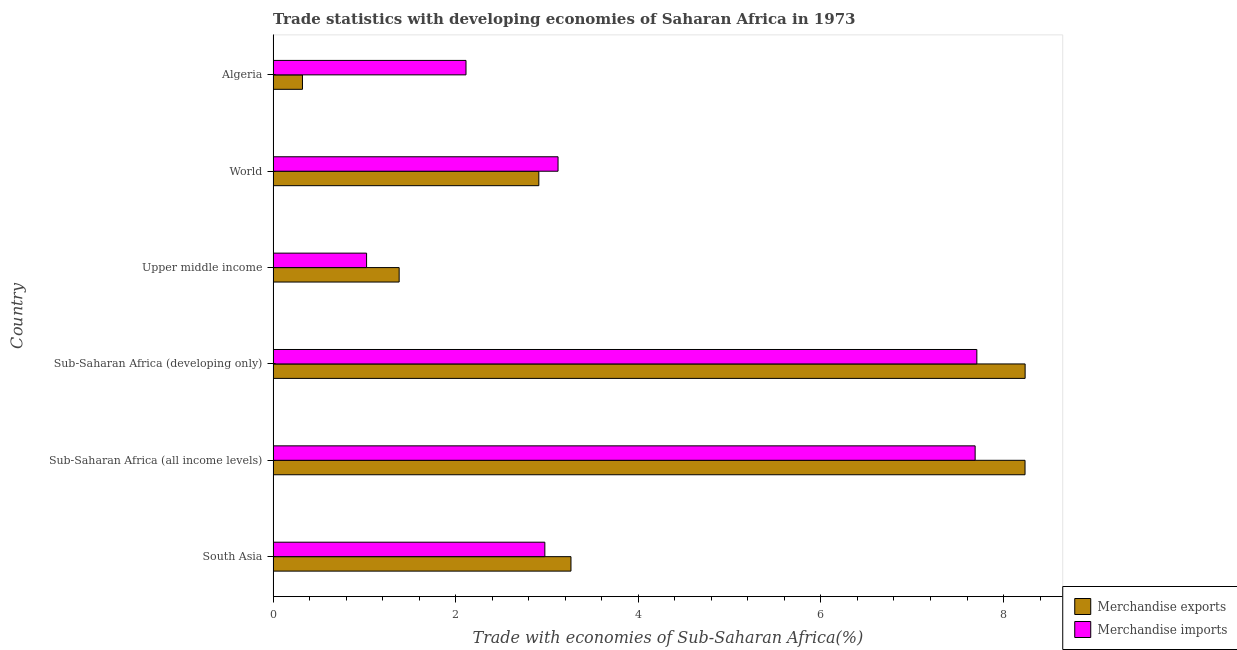How many different coloured bars are there?
Provide a succinct answer. 2. How many groups of bars are there?
Offer a very short reply. 6. Are the number of bars on each tick of the Y-axis equal?
Ensure brevity in your answer.  Yes. How many bars are there on the 6th tick from the bottom?
Your response must be concise. 2. What is the label of the 6th group of bars from the top?
Your response must be concise. South Asia. In how many cases, is the number of bars for a given country not equal to the number of legend labels?
Give a very brief answer. 0. What is the merchandise imports in South Asia?
Keep it short and to the point. 2.98. Across all countries, what is the maximum merchandise imports?
Provide a short and direct response. 7.71. Across all countries, what is the minimum merchandise exports?
Offer a very short reply. 0.32. In which country was the merchandise imports maximum?
Your response must be concise. Sub-Saharan Africa (developing only). In which country was the merchandise imports minimum?
Keep it short and to the point. Upper middle income. What is the total merchandise imports in the graph?
Make the answer very short. 24.63. What is the difference between the merchandise imports in Upper middle income and that in World?
Your answer should be compact. -2.1. What is the difference between the merchandise imports in World and the merchandise exports in Sub-Saharan Africa (developing only)?
Make the answer very short. -5.12. What is the average merchandise imports per country?
Provide a short and direct response. 4.11. What is the difference between the merchandise exports and merchandise imports in World?
Your answer should be compact. -0.21. What is the ratio of the merchandise imports in Algeria to that in South Asia?
Make the answer very short. 0.71. Is the difference between the merchandise imports in Sub-Saharan Africa (developing only) and Upper middle income greater than the difference between the merchandise exports in Sub-Saharan Africa (developing only) and Upper middle income?
Your response must be concise. No. What is the difference between the highest and the lowest merchandise exports?
Ensure brevity in your answer.  7.92. In how many countries, is the merchandise imports greater than the average merchandise imports taken over all countries?
Provide a short and direct response. 2. What does the 1st bar from the top in Upper middle income represents?
Provide a short and direct response. Merchandise imports. What is the difference between two consecutive major ticks on the X-axis?
Give a very brief answer. 2. Where does the legend appear in the graph?
Give a very brief answer. Bottom right. How are the legend labels stacked?
Your response must be concise. Vertical. What is the title of the graph?
Offer a very short reply. Trade statistics with developing economies of Saharan Africa in 1973. What is the label or title of the X-axis?
Offer a terse response. Trade with economies of Sub-Saharan Africa(%). What is the label or title of the Y-axis?
Your answer should be very brief. Country. What is the Trade with economies of Sub-Saharan Africa(%) in Merchandise exports in South Asia?
Give a very brief answer. 3.26. What is the Trade with economies of Sub-Saharan Africa(%) of Merchandise imports in South Asia?
Make the answer very short. 2.98. What is the Trade with economies of Sub-Saharan Africa(%) of Merchandise exports in Sub-Saharan Africa (all income levels)?
Provide a short and direct response. 8.24. What is the Trade with economies of Sub-Saharan Africa(%) of Merchandise imports in Sub-Saharan Africa (all income levels)?
Give a very brief answer. 7.69. What is the Trade with economies of Sub-Saharan Africa(%) in Merchandise exports in Sub-Saharan Africa (developing only)?
Provide a succinct answer. 8.24. What is the Trade with economies of Sub-Saharan Africa(%) of Merchandise imports in Sub-Saharan Africa (developing only)?
Keep it short and to the point. 7.71. What is the Trade with economies of Sub-Saharan Africa(%) of Merchandise exports in Upper middle income?
Your answer should be very brief. 1.38. What is the Trade with economies of Sub-Saharan Africa(%) of Merchandise imports in Upper middle income?
Your answer should be very brief. 1.02. What is the Trade with economies of Sub-Saharan Africa(%) in Merchandise exports in World?
Keep it short and to the point. 2.91. What is the Trade with economies of Sub-Saharan Africa(%) of Merchandise imports in World?
Give a very brief answer. 3.12. What is the Trade with economies of Sub-Saharan Africa(%) in Merchandise exports in Algeria?
Ensure brevity in your answer.  0.32. What is the Trade with economies of Sub-Saharan Africa(%) of Merchandise imports in Algeria?
Offer a very short reply. 2.11. Across all countries, what is the maximum Trade with economies of Sub-Saharan Africa(%) in Merchandise exports?
Provide a succinct answer. 8.24. Across all countries, what is the maximum Trade with economies of Sub-Saharan Africa(%) in Merchandise imports?
Make the answer very short. 7.71. Across all countries, what is the minimum Trade with economies of Sub-Saharan Africa(%) in Merchandise exports?
Ensure brevity in your answer.  0.32. Across all countries, what is the minimum Trade with economies of Sub-Saharan Africa(%) of Merchandise imports?
Offer a very short reply. 1.02. What is the total Trade with economies of Sub-Saharan Africa(%) of Merchandise exports in the graph?
Your answer should be very brief. 24.35. What is the total Trade with economies of Sub-Saharan Africa(%) of Merchandise imports in the graph?
Make the answer very short. 24.63. What is the difference between the Trade with economies of Sub-Saharan Africa(%) in Merchandise exports in South Asia and that in Sub-Saharan Africa (all income levels)?
Provide a short and direct response. -4.97. What is the difference between the Trade with economies of Sub-Saharan Africa(%) of Merchandise imports in South Asia and that in Sub-Saharan Africa (all income levels)?
Your response must be concise. -4.71. What is the difference between the Trade with economies of Sub-Saharan Africa(%) of Merchandise exports in South Asia and that in Sub-Saharan Africa (developing only)?
Your response must be concise. -4.97. What is the difference between the Trade with economies of Sub-Saharan Africa(%) in Merchandise imports in South Asia and that in Sub-Saharan Africa (developing only)?
Give a very brief answer. -4.73. What is the difference between the Trade with economies of Sub-Saharan Africa(%) of Merchandise exports in South Asia and that in Upper middle income?
Your response must be concise. 1.88. What is the difference between the Trade with economies of Sub-Saharan Africa(%) in Merchandise imports in South Asia and that in Upper middle income?
Your answer should be compact. 1.95. What is the difference between the Trade with economies of Sub-Saharan Africa(%) of Merchandise exports in South Asia and that in World?
Offer a very short reply. 0.35. What is the difference between the Trade with economies of Sub-Saharan Africa(%) in Merchandise imports in South Asia and that in World?
Your response must be concise. -0.14. What is the difference between the Trade with economies of Sub-Saharan Africa(%) of Merchandise exports in South Asia and that in Algeria?
Offer a terse response. 2.94. What is the difference between the Trade with economies of Sub-Saharan Africa(%) of Merchandise imports in South Asia and that in Algeria?
Keep it short and to the point. 0.86. What is the difference between the Trade with economies of Sub-Saharan Africa(%) in Merchandise exports in Sub-Saharan Africa (all income levels) and that in Sub-Saharan Africa (developing only)?
Offer a terse response. -0. What is the difference between the Trade with economies of Sub-Saharan Africa(%) in Merchandise imports in Sub-Saharan Africa (all income levels) and that in Sub-Saharan Africa (developing only)?
Your answer should be compact. -0.02. What is the difference between the Trade with economies of Sub-Saharan Africa(%) of Merchandise exports in Sub-Saharan Africa (all income levels) and that in Upper middle income?
Your answer should be compact. 6.86. What is the difference between the Trade with economies of Sub-Saharan Africa(%) of Merchandise imports in Sub-Saharan Africa (all income levels) and that in Upper middle income?
Your response must be concise. 6.67. What is the difference between the Trade with economies of Sub-Saharan Africa(%) in Merchandise exports in Sub-Saharan Africa (all income levels) and that in World?
Your response must be concise. 5.33. What is the difference between the Trade with economies of Sub-Saharan Africa(%) in Merchandise imports in Sub-Saharan Africa (all income levels) and that in World?
Your answer should be compact. 4.57. What is the difference between the Trade with economies of Sub-Saharan Africa(%) of Merchandise exports in Sub-Saharan Africa (all income levels) and that in Algeria?
Give a very brief answer. 7.91. What is the difference between the Trade with economies of Sub-Saharan Africa(%) in Merchandise imports in Sub-Saharan Africa (all income levels) and that in Algeria?
Offer a terse response. 5.58. What is the difference between the Trade with economies of Sub-Saharan Africa(%) of Merchandise exports in Sub-Saharan Africa (developing only) and that in Upper middle income?
Keep it short and to the point. 6.86. What is the difference between the Trade with economies of Sub-Saharan Africa(%) of Merchandise imports in Sub-Saharan Africa (developing only) and that in Upper middle income?
Your answer should be compact. 6.68. What is the difference between the Trade with economies of Sub-Saharan Africa(%) in Merchandise exports in Sub-Saharan Africa (developing only) and that in World?
Ensure brevity in your answer.  5.33. What is the difference between the Trade with economies of Sub-Saharan Africa(%) of Merchandise imports in Sub-Saharan Africa (developing only) and that in World?
Offer a terse response. 4.59. What is the difference between the Trade with economies of Sub-Saharan Africa(%) in Merchandise exports in Sub-Saharan Africa (developing only) and that in Algeria?
Make the answer very short. 7.92. What is the difference between the Trade with economies of Sub-Saharan Africa(%) in Merchandise imports in Sub-Saharan Africa (developing only) and that in Algeria?
Your answer should be very brief. 5.6. What is the difference between the Trade with economies of Sub-Saharan Africa(%) in Merchandise exports in Upper middle income and that in World?
Provide a short and direct response. -1.53. What is the difference between the Trade with economies of Sub-Saharan Africa(%) in Merchandise imports in Upper middle income and that in World?
Offer a very short reply. -2.1. What is the difference between the Trade with economies of Sub-Saharan Africa(%) in Merchandise exports in Upper middle income and that in Algeria?
Make the answer very short. 1.06. What is the difference between the Trade with economies of Sub-Saharan Africa(%) of Merchandise imports in Upper middle income and that in Algeria?
Offer a very short reply. -1.09. What is the difference between the Trade with economies of Sub-Saharan Africa(%) in Merchandise exports in World and that in Algeria?
Your answer should be very brief. 2.59. What is the difference between the Trade with economies of Sub-Saharan Africa(%) of Merchandise imports in World and that in Algeria?
Offer a terse response. 1.01. What is the difference between the Trade with economies of Sub-Saharan Africa(%) in Merchandise exports in South Asia and the Trade with economies of Sub-Saharan Africa(%) in Merchandise imports in Sub-Saharan Africa (all income levels)?
Give a very brief answer. -4.43. What is the difference between the Trade with economies of Sub-Saharan Africa(%) in Merchandise exports in South Asia and the Trade with economies of Sub-Saharan Africa(%) in Merchandise imports in Sub-Saharan Africa (developing only)?
Offer a very short reply. -4.45. What is the difference between the Trade with economies of Sub-Saharan Africa(%) of Merchandise exports in South Asia and the Trade with economies of Sub-Saharan Africa(%) of Merchandise imports in Upper middle income?
Provide a succinct answer. 2.24. What is the difference between the Trade with economies of Sub-Saharan Africa(%) of Merchandise exports in South Asia and the Trade with economies of Sub-Saharan Africa(%) of Merchandise imports in World?
Keep it short and to the point. 0.14. What is the difference between the Trade with economies of Sub-Saharan Africa(%) of Merchandise exports in South Asia and the Trade with economies of Sub-Saharan Africa(%) of Merchandise imports in Algeria?
Your response must be concise. 1.15. What is the difference between the Trade with economies of Sub-Saharan Africa(%) of Merchandise exports in Sub-Saharan Africa (all income levels) and the Trade with economies of Sub-Saharan Africa(%) of Merchandise imports in Sub-Saharan Africa (developing only)?
Provide a succinct answer. 0.53. What is the difference between the Trade with economies of Sub-Saharan Africa(%) of Merchandise exports in Sub-Saharan Africa (all income levels) and the Trade with economies of Sub-Saharan Africa(%) of Merchandise imports in Upper middle income?
Provide a short and direct response. 7.21. What is the difference between the Trade with economies of Sub-Saharan Africa(%) in Merchandise exports in Sub-Saharan Africa (all income levels) and the Trade with economies of Sub-Saharan Africa(%) in Merchandise imports in World?
Make the answer very short. 5.12. What is the difference between the Trade with economies of Sub-Saharan Africa(%) in Merchandise exports in Sub-Saharan Africa (all income levels) and the Trade with economies of Sub-Saharan Africa(%) in Merchandise imports in Algeria?
Your answer should be compact. 6.12. What is the difference between the Trade with economies of Sub-Saharan Africa(%) in Merchandise exports in Sub-Saharan Africa (developing only) and the Trade with economies of Sub-Saharan Africa(%) in Merchandise imports in Upper middle income?
Provide a short and direct response. 7.21. What is the difference between the Trade with economies of Sub-Saharan Africa(%) of Merchandise exports in Sub-Saharan Africa (developing only) and the Trade with economies of Sub-Saharan Africa(%) of Merchandise imports in World?
Offer a terse response. 5.12. What is the difference between the Trade with economies of Sub-Saharan Africa(%) of Merchandise exports in Sub-Saharan Africa (developing only) and the Trade with economies of Sub-Saharan Africa(%) of Merchandise imports in Algeria?
Provide a short and direct response. 6.12. What is the difference between the Trade with economies of Sub-Saharan Africa(%) of Merchandise exports in Upper middle income and the Trade with economies of Sub-Saharan Africa(%) of Merchandise imports in World?
Make the answer very short. -1.74. What is the difference between the Trade with economies of Sub-Saharan Africa(%) of Merchandise exports in Upper middle income and the Trade with economies of Sub-Saharan Africa(%) of Merchandise imports in Algeria?
Make the answer very short. -0.73. What is the difference between the Trade with economies of Sub-Saharan Africa(%) of Merchandise exports in World and the Trade with economies of Sub-Saharan Africa(%) of Merchandise imports in Algeria?
Keep it short and to the point. 0.8. What is the average Trade with economies of Sub-Saharan Africa(%) of Merchandise exports per country?
Offer a very short reply. 4.06. What is the average Trade with economies of Sub-Saharan Africa(%) in Merchandise imports per country?
Your answer should be very brief. 4.11. What is the difference between the Trade with economies of Sub-Saharan Africa(%) in Merchandise exports and Trade with economies of Sub-Saharan Africa(%) in Merchandise imports in South Asia?
Provide a succinct answer. 0.29. What is the difference between the Trade with economies of Sub-Saharan Africa(%) in Merchandise exports and Trade with economies of Sub-Saharan Africa(%) in Merchandise imports in Sub-Saharan Africa (all income levels)?
Your answer should be very brief. 0.55. What is the difference between the Trade with economies of Sub-Saharan Africa(%) in Merchandise exports and Trade with economies of Sub-Saharan Africa(%) in Merchandise imports in Sub-Saharan Africa (developing only)?
Make the answer very short. 0.53. What is the difference between the Trade with economies of Sub-Saharan Africa(%) in Merchandise exports and Trade with economies of Sub-Saharan Africa(%) in Merchandise imports in Upper middle income?
Offer a very short reply. 0.36. What is the difference between the Trade with economies of Sub-Saharan Africa(%) in Merchandise exports and Trade with economies of Sub-Saharan Africa(%) in Merchandise imports in World?
Your response must be concise. -0.21. What is the difference between the Trade with economies of Sub-Saharan Africa(%) in Merchandise exports and Trade with economies of Sub-Saharan Africa(%) in Merchandise imports in Algeria?
Provide a short and direct response. -1.79. What is the ratio of the Trade with economies of Sub-Saharan Africa(%) in Merchandise exports in South Asia to that in Sub-Saharan Africa (all income levels)?
Provide a succinct answer. 0.4. What is the ratio of the Trade with economies of Sub-Saharan Africa(%) of Merchandise imports in South Asia to that in Sub-Saharan Africa (all income levels)?
Make the answer very short. 0.39. What is the ratio of the Trade with economies of Sub-Saharan Africa(%) in Merchandise exports in South Asia to that in Sub-Saharan Africa (developing only)?
Offer a very short reply. 0.4. What is the ratio of the Trade with economies of Sub-Saharan Africa(%) in Merchandise imports in South Asia to that in Sub-Saharan Africa (developing only)?
Your answer should be very brief. 0.39. What is the ratio of the Trade with economies of Sub-Saharan Africa(%) of Merchandise exports in South Asia to that in Upper middle income?
Keep it short and to the point. 2.36. What is the ratio of the Trade with economies of Sub-Saharan Africa(%) in Merchandise imports in South Asia to that in Upper middle income?
Ensure brevity in your answer.  2.91. What is the ratio of the Trade with economies of Sub-Saharan Africa(%) of Merchandise exports in South Asia to that in World?
Make the answer very short. 1.12. What is the ratio of the Trade with economies of Sub-Saharan Africa(%) of Merchandise imports in South Asia to that in World?
Make the answer very short. 0.95. What is the ratio of the Trade with economies of Sub-Saharan Africa(%) in Merchandise exports in South Asia to that in Algeria?
Offer a very short reply. 10.15. What is the ratio of the Trade with economies of Sub-Saharan Africa(%) of Merchandise imports in South Asia to that in Algeria?
Make the answer very short. 1.41. What is the ratio of the Trade with economies of Sub-Saharan Africa(%) of Merchandise exports in Sub-Saharan Africa (all income levels) to that in Upper middle income?
Your answer should be compact. 5.97. What is the ratio of the Trade with economies of Sub-Saharan Africa(%) in Merchandise imports in Sub-Saharan Africa (all income levels) to that in Upper middle income?
Ensure brevity in your answer.  7.51. What is the ratio of the Trade with economies of Sub-Saharan Africa(%) in Merchandise exports in Sub-Saharan Africa (all income levels) to that in World?
Keep it short and to the point. 2.83. What is the ratio of the Trade with economies of Sub-Saharan Africa(%) of Merchandise imports in Sub-Saharan Africa (all income levels) to that in World?
Provide a succinct answer. 2.46. What is the ratio of the Trade with economies of Sub-Saharan Africa(%) of Merchandise exports in Sub-Saharan Africa (all income levels) to that in Algeria?
Offer a very short reply. 25.62. What is the ratio of the Trade with economies of Sub-Saharan Africa(%) in Merchandise imports in Sub-Saharan Africa (all income levels) to that in Algeria?
Your response must be concise. 3.64. What is the ratio of the Trade with economies of Sub-Saharan Africa(%) in Merchandise exports in Sub-Saharan Africa (developing only) to that in Upper middle income?
Ensure brevity in your answer.  5.97. What is the ratio of the Trade with economies of Sub-Saharan Africa(%) of Merchandise imports in Sub-Saharan Africa (developing only) to that in Upper middle income?
Offer a very short reply. 7.53. What is the ratio of the Trade with economies of Sub-Saharan Africa(%) of Merchandise exports in Sub-Saharan Africa (developing only) to that in World?
Provide a succinct answer. 2.83. What is the ratio of the Trade with economies of Sub-Saharan Africa(%) of Merchandise imports in Sub-Saharan Africa (developing only) to that in World?
Make the answer very short. 2.47. What is the ratio of the Trade with economies of Sub-Saharan Africa(%) of Merchandise exports in Sub-Saharan Africa (developing only) to that in Algeria?
Provide a short and direct response. 25.62. What is the ratio of the Trade with economies of Sub-Saharan Africa(%) in Merchandise imports in Sub-Saharan Africa (developing only) to that in Algeria?
Offer a terse response. 3.65. What is the ratio of the Trade with economies of Sub-Saharan Africa(%) of Merchandise exports in Upper middle income to that in World?
Offer a terse response. 0.47. What is the ratio of the Trade with economies of Sub-Saharan Africa(%) in Merchandise imports in Upper middle income to that in World?
Offer a very short reply. 0.33. What is the ratio of the Trade with economies of Sub-Saharan Africa(%) in Merchandise exports in Upper middle income to that in Algeria?
Provide a succinct answer. 4.29. What is the ratio of the Trade with economies of Sub-Saharan Africa(%) in Merchandise imports in Upper middle income to that in Algeria?
Your response must be concise. 0.48. What is the ratio of the Trade with economies of Sub-Saharan Africa(%) of Merchandise exports in World to that in Algeria?
Offer a terse response. 9.05. What is the ratio of the Trade with economies of Sub-Saharan Africa(%) of Merchandise imports in World to that in Algeria?
Your response must be concise. 1.48. What is the difference between the highest and the second highest Trade with economies of Sub-Saharan Africa(%) in Merchandise exports?
Keep it short and to the point. 0. What is the difference between the highest and the second highest Trade with economies of Sub-Saharan Africa(%) of Merchandise imports?
Offer a terse response. 0.02. What is the difference between the highest and the lowest Trade with economies of Sub-Saharan Africa(%) in Merchandise exports?
Provide a succinct answer. 7.92. What is the difference between the highest and the lowest Trade with economies of Sub-Saharan Africa(%) of Merchandise imports?
Your answer should be very brief. 6.68. 